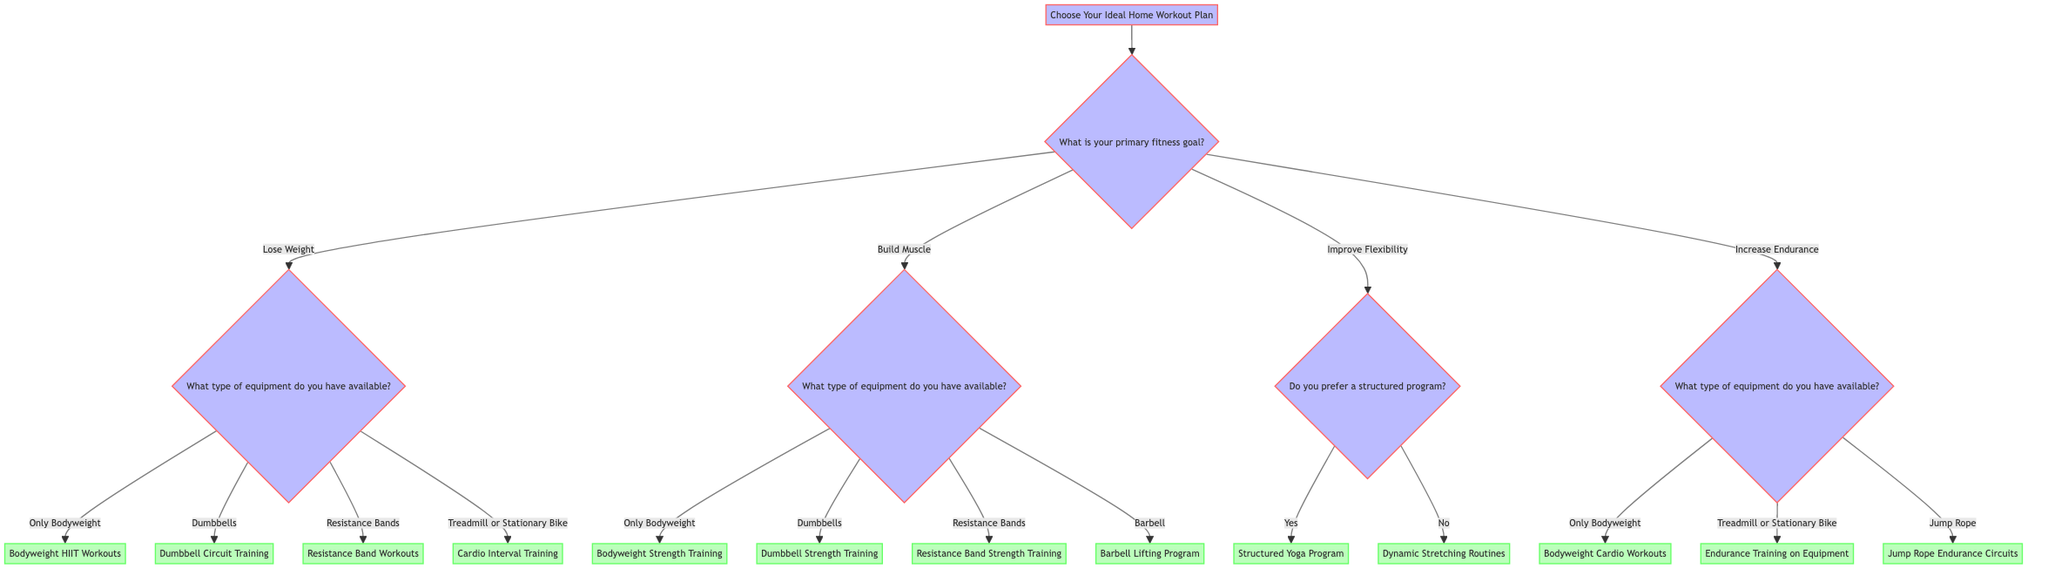What is the primary purpose of the diagram? The diagram's purpose is to guide users in choosing an ideal home workout plan based on their fitness goals and available equipment.
Answer: Guiding users in choosing a workout plan How many primary fitness goals are presented in the diagram? The diagram lists four primary fitness goals: Lose Weight, Build Muscle, Improve Flexibility, and Increase Endurance. Counting these options gives a total of four goals.
Answer: Four If someone wants to improve flexibility, what question do they answer next? If the primary fitness goal is to Improve Flexibility, the next question asked is about the preference for a structured program. This is clearly depicted as the next step in the flow for that goal.
Answer: Do you prefer a structured program? What type of workout plan is suggested if the goal is to build muscle and the person has dumbbells available? Following the flow for Build Muscle and selecting the option for Dumbbells leads directly to the outcome of Dumbbell Strength Training. The answer is derived from tracing the connections in the diagram.
Answer: Dumbbell Strength Training How many options are given for the type of equipment when trying to lose weight? When attempting to lose weight, there are four equipment options presented: Only Bodyweight, Dumbbells, Resistance Bands, and Treadmill or Stationary Bike. Counting these options results in four distinct paths in the decision tree.
Answer: Four What would be suggested for someone with a treadmill and a goal of increasing endurance? Tracing the path for Increasing Endurance to the option of having Treadmill or Stationary Bike leads to the suggestion of Endurance Training on Equipment. The answer is reached by following the corresponding branches in the diagram.
Answer: Endurance Training on Equipment If a person has only bodyweight available and wants to lose weight, what is the suggested workout plan? The logical flow for Losing Weight when only Bodyweight is available points to Bodyweight HIIT Workouts as the suggested plan. This is a direct conclusion from the decision tree paths.
Answer: Bodyweight HIIT Workouts What type of workout plan is recommended for someone who prefers a non-structured approach to flexibility training? If a person answers "No" to the structured program question after selecting Improve Flexibility, the recommended plan is Dynamic Stretching Routines. This is derived from following the path for the preference indicated.
Answer: Dynamic Stretching Routines 